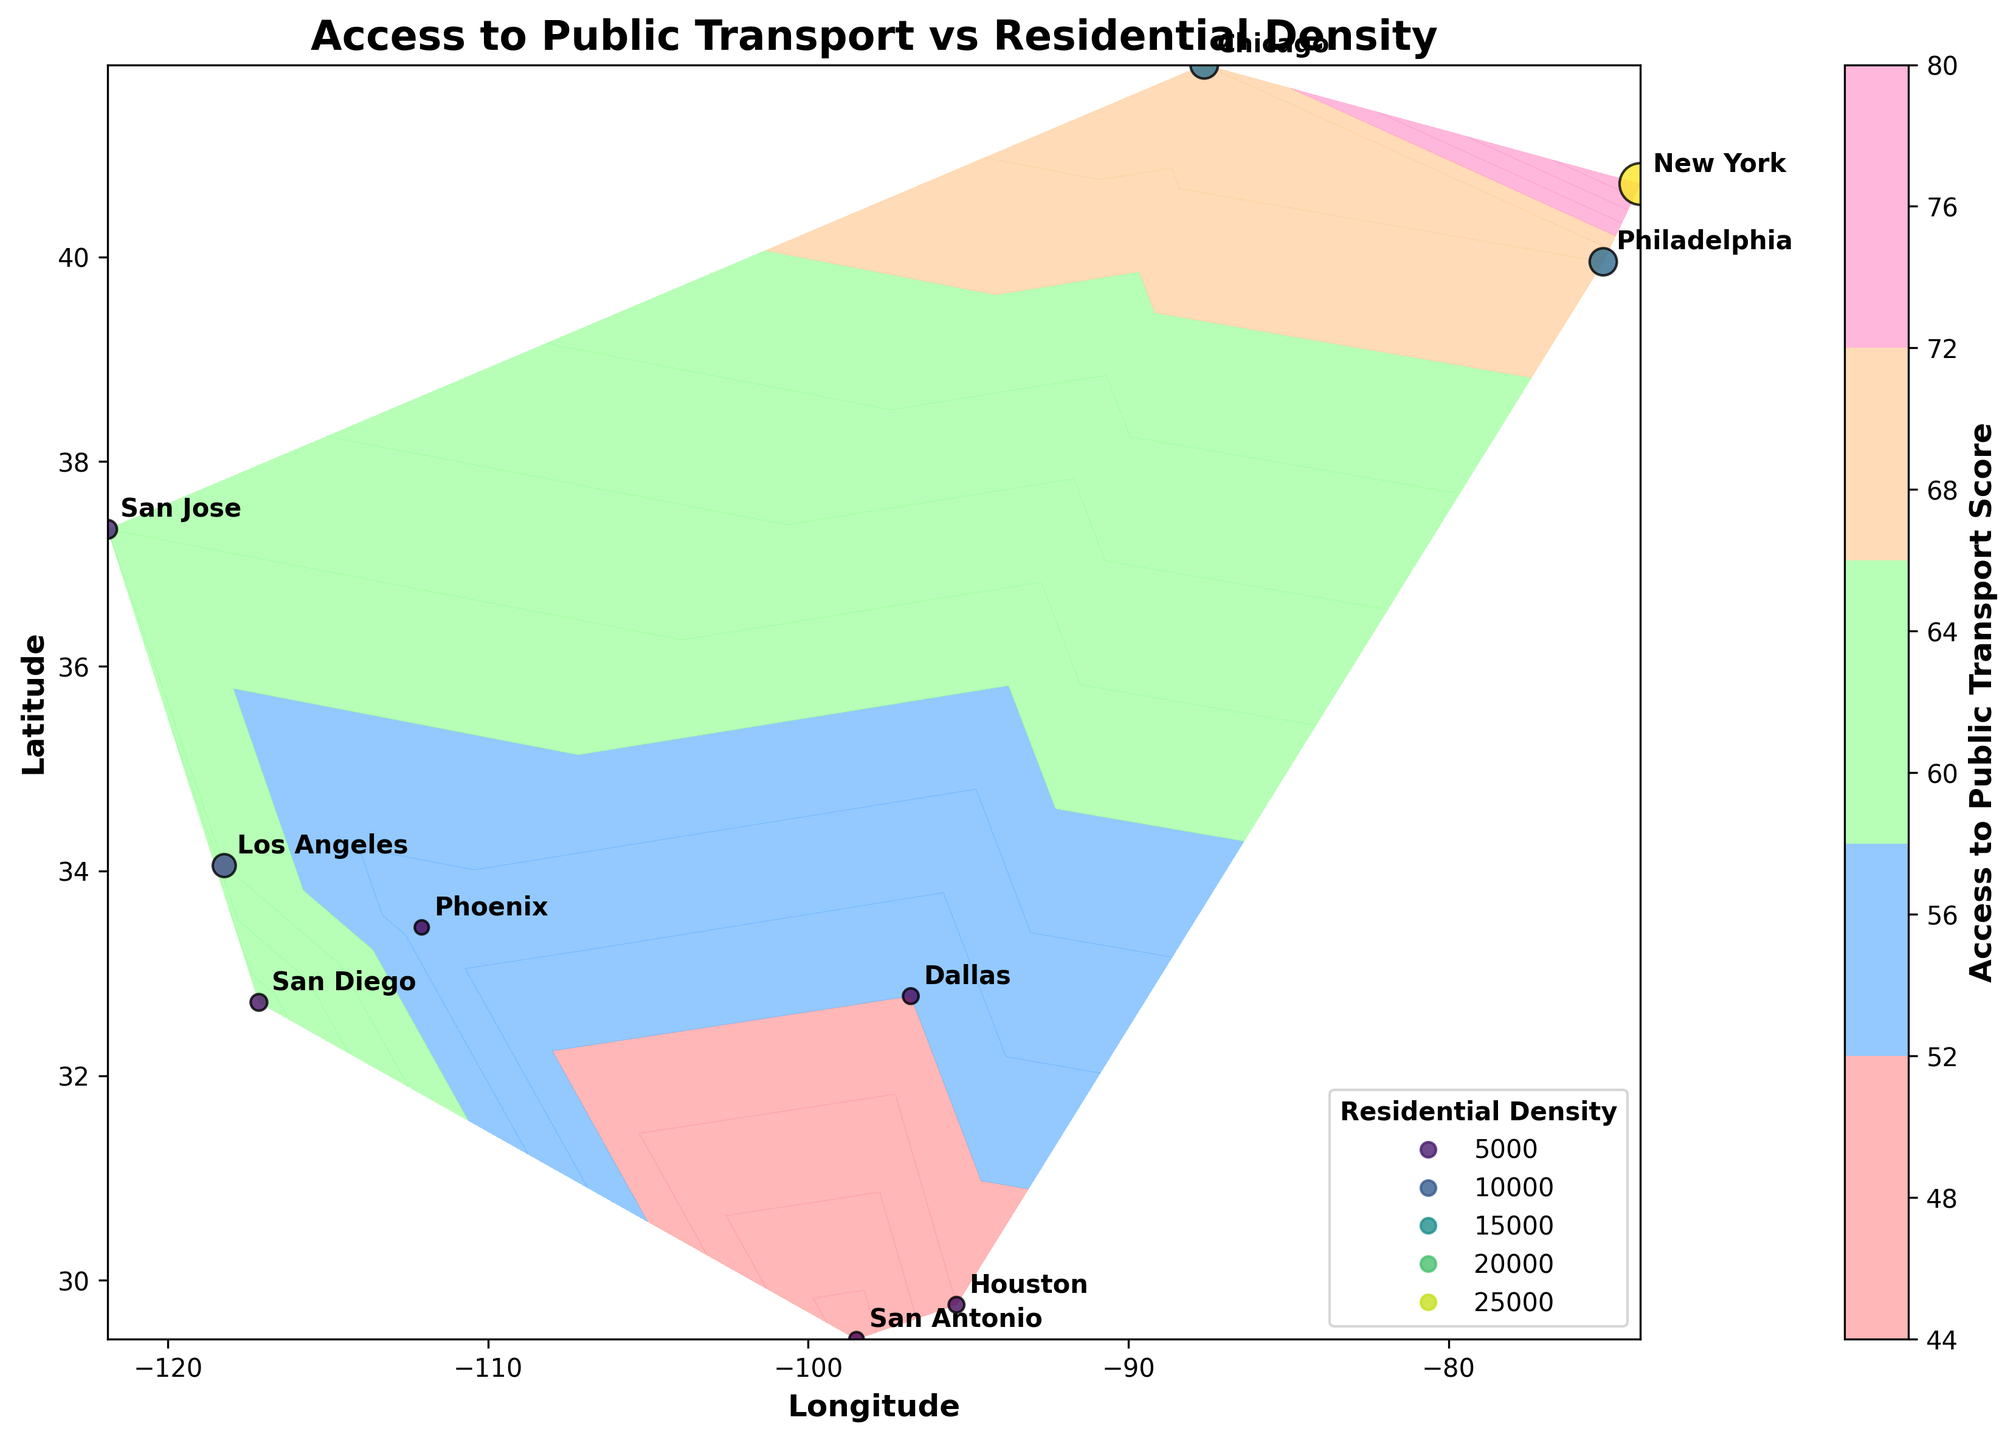How many cities are depicted on the contour plot? The plot shows labels and markers for each city, which we can count directly.
Answer: 10 What are the axis labels for the contour plot? The labels next to each axis indicate what they represent.
Answer: Longitude and Latitude Which city has the highest Access to Public Transport Score? By checking the scores labeled on the contour plot, we can identify the highest score.
Answer: New York Which city has the highest Residential Density? The size of the markers and the numerical labels indicate residential density. The largest marker with the highest density label can be identified.
Answer: New York What is the range of Access to Public Transport Scores depicted in the contour plot? By looking at the colorbar, we can determine the minimum and maximum score levels.
Answer: 45 to 80 Which city has both the lowest Access to Public Transport Score and Residential Density? We can identify the lowest score and the corresponding smallest marker on the plot.
Answer: San Antonio Between Phoenix and Houston, which city has better access to public transport? By comparing the Access to Public Transport Scores labeled near the markers of Phoenix and Houston.
Answer: Phoenix What characteristic is represented by the color of the filled contours? The colorbar explains what the colors of the filled contours represent.
Answer: Access to Public Transport Score Which cities are located closest to each other based on their longitude and latitude? By examining the layout of city markers and their relative distances.
Answer: San Antonio and Houston Which city shows a higher residential density, San Diego or San Jose? By comparing the marker sizes and their corresponding Residential Density labels.
Answer: San Jose 